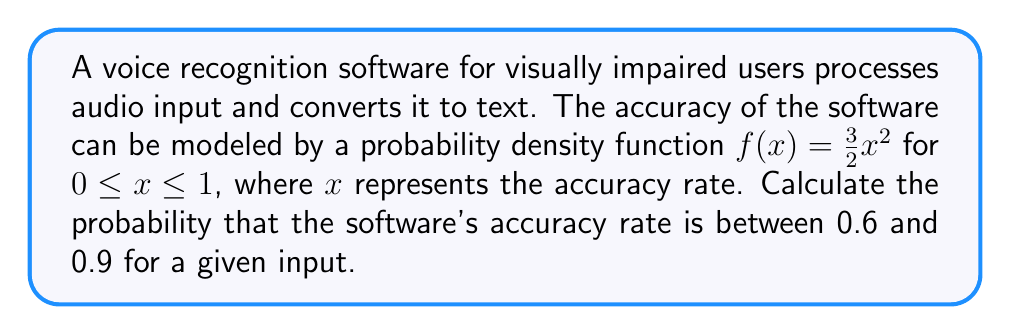Provide a solution to this math problem. To solve this problem, we need to integrate the probability density function over the given interval. Here's the step-by-step solution:

1. The probability density function is given as $f(x) = \frac{3}{2}x^2$ for $0 \leq x \leq 1$.

2. We need to find the probability for the interval $[0.6, 0.9]$, which can be calculated by integrating $f(x)$ over this interval:

   $$P(0.6 \leq x \leq 0.9) = \int_{0.6}^{0.9} f(x) dx = \int_{0.6}^{0.9} \frac{3}{2}x^2 dx$$

3. Integrate the function:
   $$\int_{0.6}^{0.9} \frac{3}{2}x^2 dx = \frac{3}{2} \int_{0.6}^{0.9} x^2 dx = \frac{3}{2} \left[ \frac{x^3}{3} \right]_{0.6}^{0.9}$$

4. Evaluate the integral:
   $$\frac{3}{2} \left[ \frac{0.9^3}{3} - \frac{0.6^3}{3} \right] = \frac{1}{2} [0.9^3 - 0.6^3]$$

5. Calculate the final result:
   $$\frac{1}{2} [0.729 - 0.216] = \frac{1}{2} (0.513) = 0.2565$$

Therefore, the probability that the software's accuracy rate is between 0.6 and 0.9 is approximately 0.2565 or 25.65%.
Answer: 0.2565 